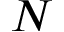Convert formula to latex. <formula><loc_0><loc_0><loc_500><loc_500>N</formula> 